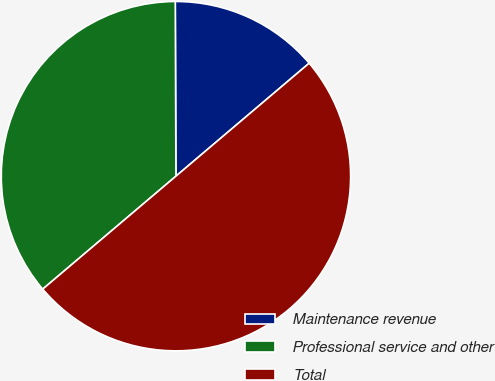Convert chart. <chart><loc_0><loc_0><loc_500><loc_500><pie_chart><fcel>Maintenance revenue<fcel>Professional service and other<fcel>Total<nl><fcel>13.87%<fcel>36.13%<fcel>50.0%<nl></chart> 